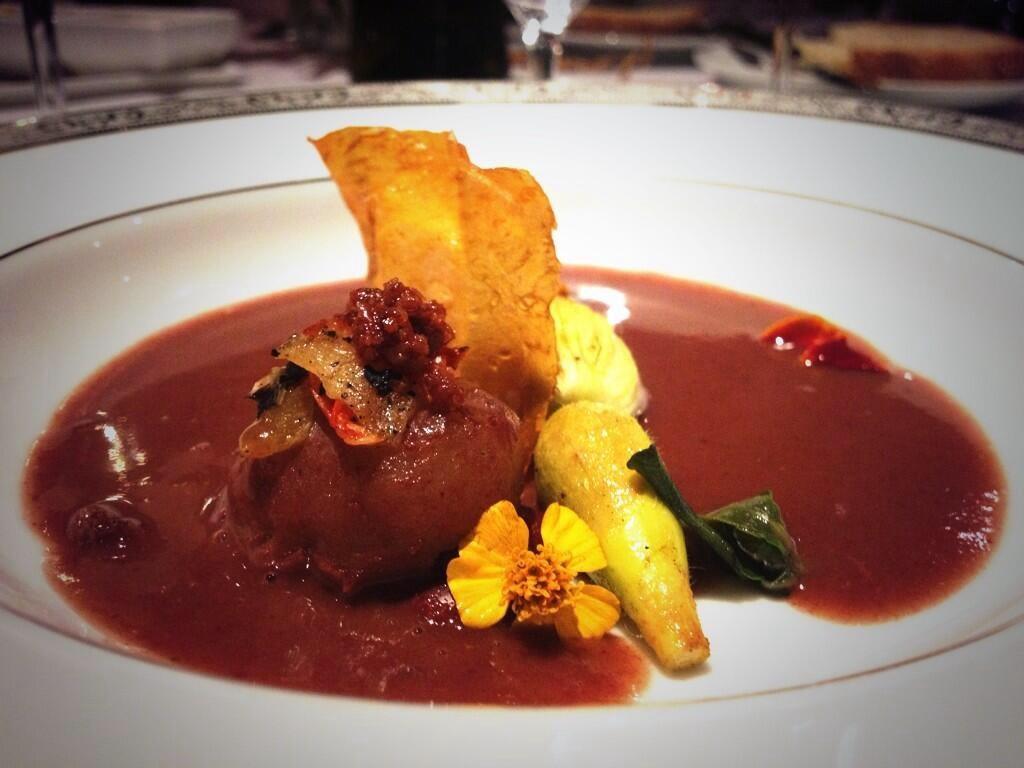In one or two sentences, can you explain what this image depicts? In this image I can see food in the plate. 